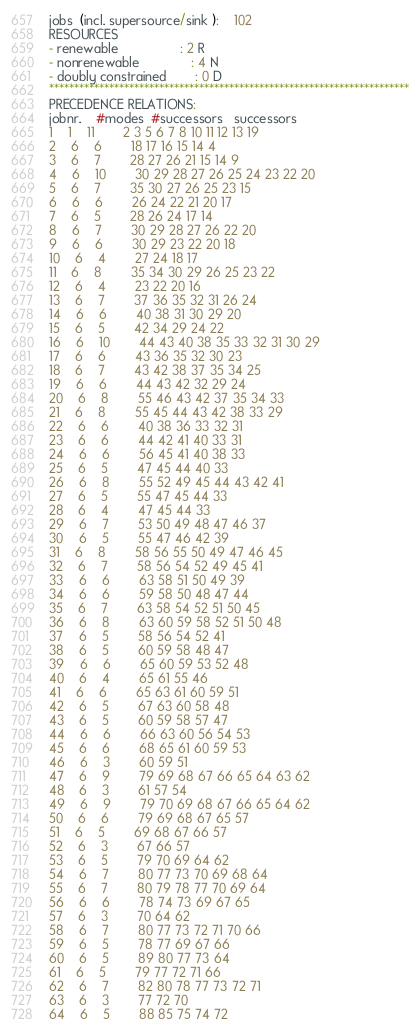<code> <loc_0><loc_0><loc_500><loc_500><_ObjectiveC_>jobs  (incl. supersource/sink ):	102
RESOURCES
- renewable                 : 2 R
- nonrenewable              : 4 N
- doubly constrained        : 0 D
************************************************************************
PRECEDENCE RELATIONS:
jobnr.    #modes  #successors   successors
1	1	11		2 3 5 6 7 8 10 11 12 13 19 
2	6	6		18 17 16 15 14 4 
3	6	7		28 27 26 21 15 14 9 
4	6	10		30 29 28 27 26 25 24 23 22 20 
5	6	7		35 30 27 26 25 23 15 
6	6	6		26 24 22 21 20 17 
7	6	5		28 26 24 17 14 
8	6	7		30 29 28 27 26 22 20 
9	6	6		30 29 23 22 20 18 
10	6	4		27 24 18 17 
11	6	8		35 34 30 29 26 25 23 22 
12	6	4		23 22 20 16 
13	6	7		37 36 35 32 31 26 24 
14	6	6		40 38 31 30 29 20 
15	6	5		42 34 29 24 22 
16	6	10		44 43 40 38 35 33 32 31 30 29 
17	6	6		43 36 35 32 30 23 
18	6	7		43 42 38 37 35 34 25 
19	6	6		44 43 42 32 29 24 
20	6	8		55 46 43 42 37 35 34 33 
21	6	8		55 45 44 43 42 38 33 29 
22	6	6		40 38 36 33 32 31 
23	6	6		44 42 41 40 33 31 
24	6	6		56 45 41 40 38 33 
25	6	5		47 45 44 40 33 
26	6	8		55 52 49 45 44 43 42 41 
27	6	5		55 47 45 44 33 
28	6	4		47 45 44 33 
29	6	7		53 50 49 48 47 46 37 
30	6	5		55 47 46 42 39 
31	6	8		58 56 55 50 49 47 46 45 
32	6	7		58 56 54 52 49 45 41 
33	6	6		63 58 51 50 49 39 
34	6	6		59 58 50 48 47 44 
35	6	7		63 58 54 52 51 50 45 
36	6	8		63 60 59 58 52 51 50 48 
37	6	5		58 56 54 52 41 
38	6	5		60 59 58 48 47 
39	6	6		65 60 59 53 52 48 
40	6	4		65 61 55 46 
41	6	6		65 63 61 60 59 51 
42	6	5		67 63 60 58 48 
43	6	5		60 59 58 57 47 
44	6	6		66 63 60 56 54 53 
45	6	6		68 65 61 60 59 53 
46	6	3		60 59 51 
47	6	9		79 69 68 67 66 65 64 63 62 
48	6	3		61 57 54 
49	6	9		79 70 69 68 67 66 65 64 62 
50	6	6		79 69 68 67 65 57 
51	6	5		69 68 67 66 57 
52	6	3		67 66 57 
53	6	5		79 70 69 64 62 
54	6	7		80 77 73 70 69 68 64 
55	6	7		80 79 78 77 70 69 64 
56	6	6		78 74 73 69 67 65 
57	6	3		70 64 62 
58	6	7		80 77 73 72 71 70 66 
59	6	5		78 77 69 67 66 
60	6	5		89 80 77 73 64 
61	6	5		79 77 72 71 66 
62	6	7		82 80 78 77 73 72 71 
63	6	3		77 72 70 
64	6	5		88 85 75 74 72 </code> 